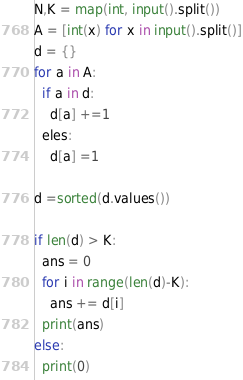Convert code to text. <code><loc_0><loc_0><loc_500><loc_500><_Python_>N,K = map(int, input().split())
A = [int(x) for x in input().split()]
d = {}
for a in A:
  if a in d:
    d[a] +=1
  eles:
    d[a] =1
    
d =sorted(d.values())

if len(d) > K:
  ans = 0
  for i in range(len(d)-K):
    ans += d[i]
  print(ans)
else:
  print(0)
</code> 